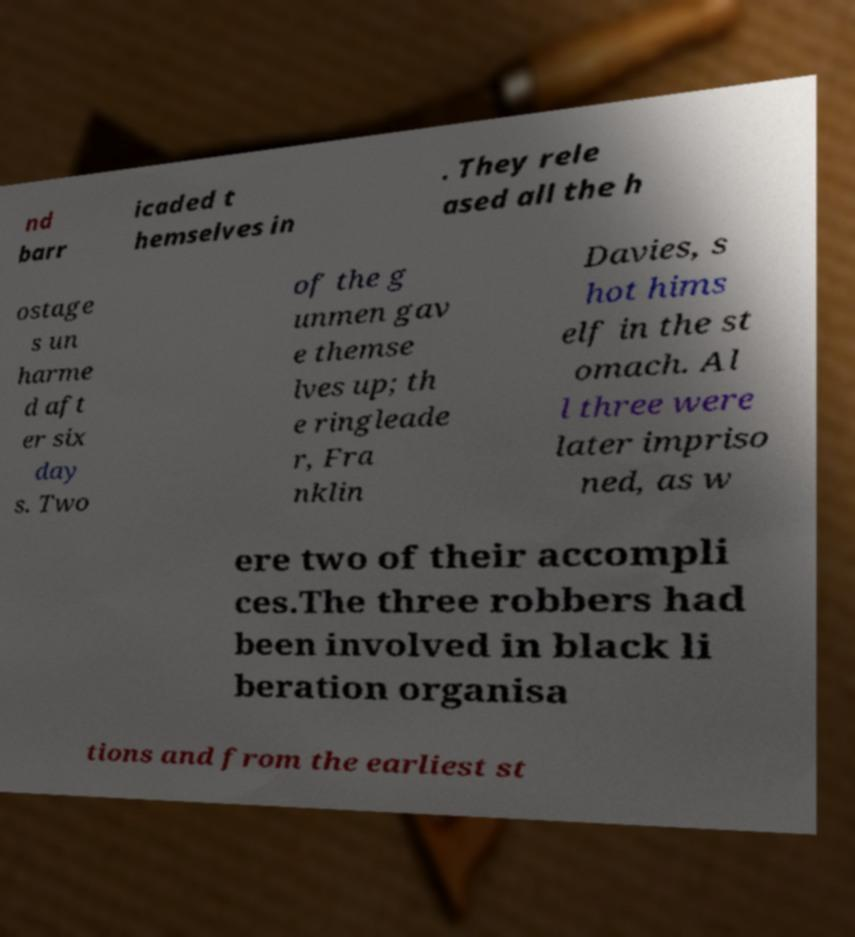For documentation purposes, I need the text within this image transcribed. Could you provide that? nd barr icaded t hemselves in . They rele ased all the h ostage s un harme d aft er six day s. Two of the g unmen gav e themse lves up; th e ringleade r, Fra nklin Davies, s hot hims elf in the st omach. Al l three were later impriso ned, as w ere two of their accompli ces.The three robbers had been involved in black li beration organisa tions and from the earliest st 